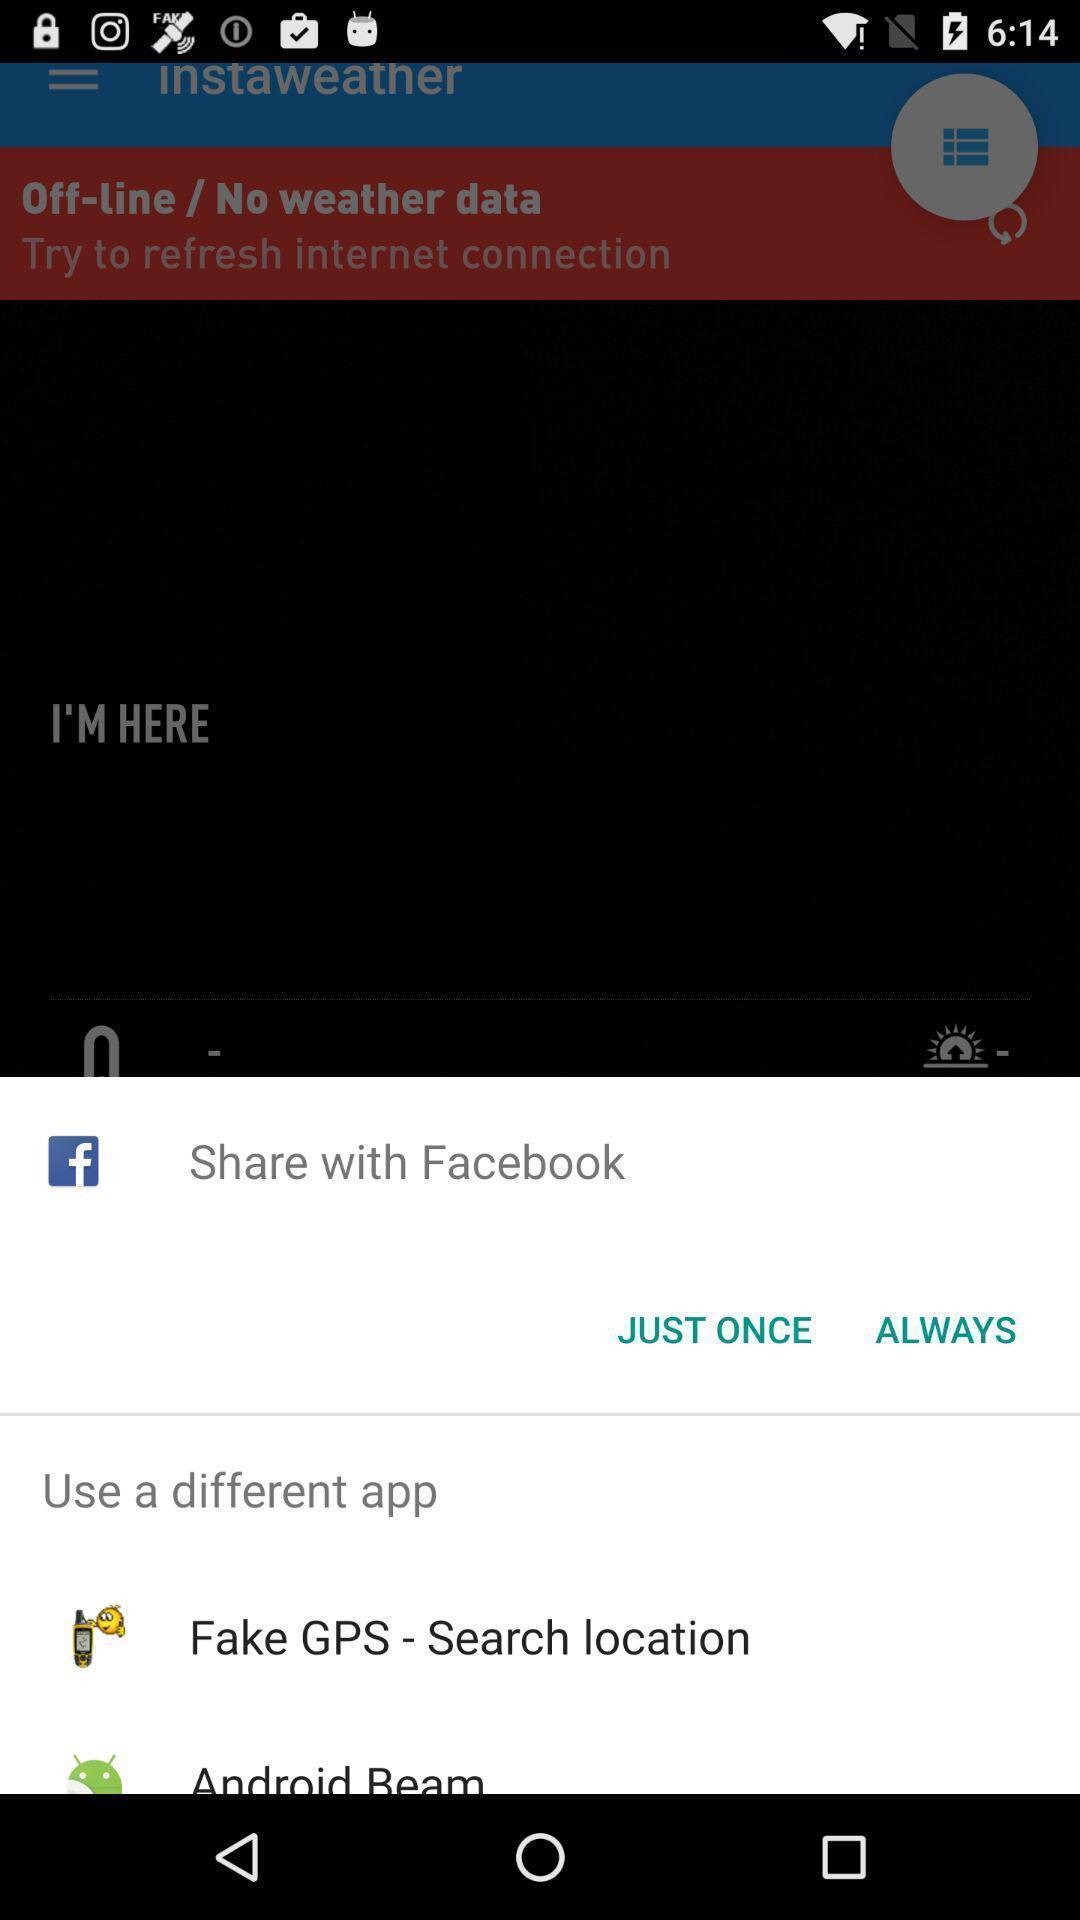Please provide a description for this image. Popup showing different options to share the file. 